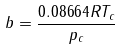<formula> <loc_0><loc_0><loc_500><loc_500>b = \frac { 0 . 0 8 6 6 4 R T _ { c } } { p _ { c } }</formula> 